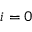Convert formula to latex. <formula><loc_0><loc_0><loc_500><loc_500>i = 0</formula> 